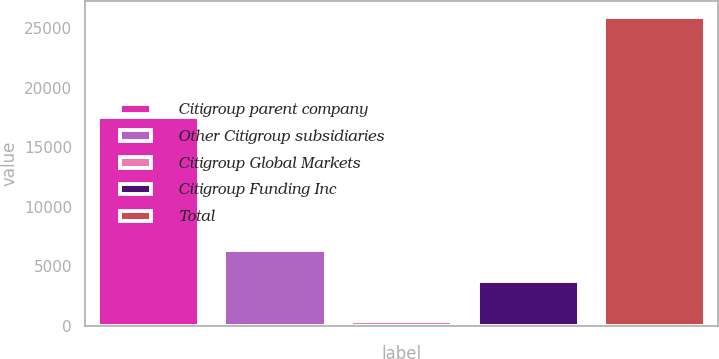Convert chart to OTSL. <chart><loc_0><loc_0><loc_500><loc_500><bar_chart><fcel>Citigroup parent company<fcel>Other Citigroup subsidiaries<fcel>Citigroup Global Markets<fcel>Citigroup Funding Inc<fcel>Total<nl><fcel>17525<fcel>6346.3<fcel>392<fcel>3790<fcel>25955<nl></chart> 